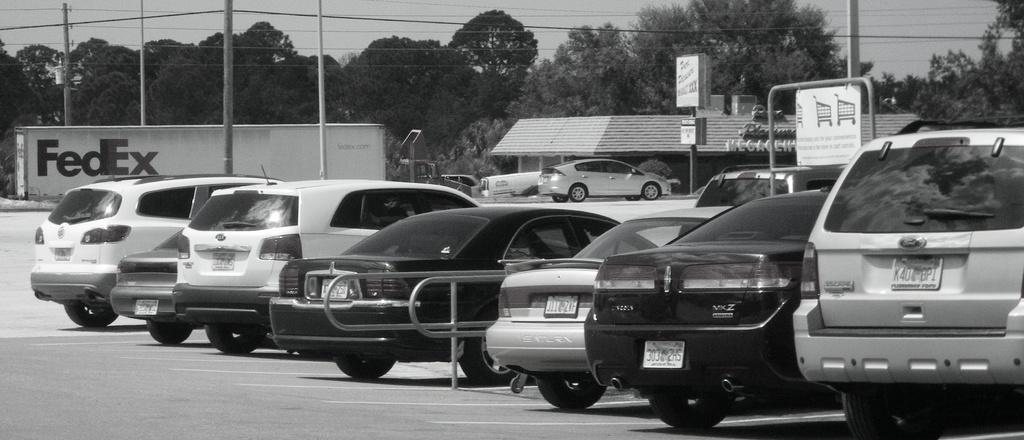Could you give a brief overview of what you see in this image? It is a black and white picture. In this picture I can see vehicles, store, poles, boards, plants, trees, sky and objects. 